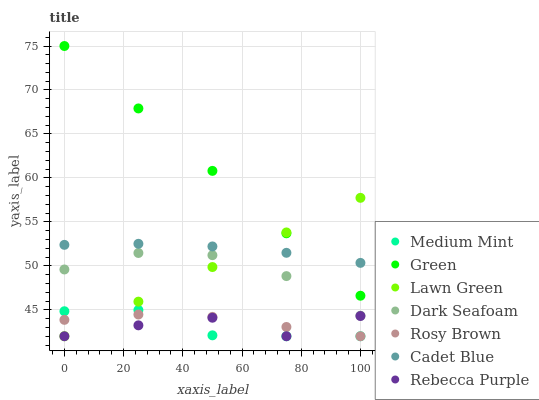Does Rebecca Purple have the minimum area under the curve?
Answer yes or no. Yes. Does Green have the maximum area under the curve?
Answer yes or no. Yes. Does Lawn Green have the minimum area under the curve?
Answer yes or no. No. Does Lawn Green have the maximum area under the curve?
Answer yes or no. No. Is Lawn Green the smoothest?
Answer yes or no. Yes. Is Rebecca Purple the roughest?
Answer yes or no. Yes. Is Cadet Blue the smoothest?
Answer yes or no. No. Is Cadet Blue the roughest?
Answer yes or no. No. Does Medium Mint have the lowest value?
Answer yes or no. Yes. Does Cadet Blue have the lowest value?
Answer yes or no. No. Does Green have the highest value?
Answer yes or no. Yes. Does Lawn Green have the highest value?
Answer yes or no. No. Is Rosy Brown less than Dark Seafoam?
Answer yes or no. Yes. Is Cadet Blue greater than Rebecca Purple?
Answer yes or no. Yes. Does Rebecca Purple intersect Lawn Green?
Answer yes or no. Yes. Is Rebecca Purple less than Lawn Green?
Answer yes or no. No. Is Rebecca Purple greater than Lawn Green?
Answer yes or no. No. Does Rosy Brown intersect Dark Seafoam?
Answer yes or no. No. 